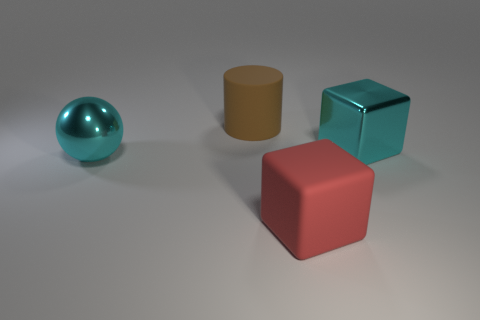Are there any cyan things left of the big cyan cube?
Provide a succinct answer. Yes. There is a large cyan metallic thing to the left of the cyan block; what number of cyan things are to the right of it?
Provide a succinct answer. 1. There is a cylinder that is the same size as the red rubber cube; what is it made of?
Give a very brief answer. Rubber. How many other things are made of the same material as the large cyan cube?
Offer a terse response. 1. There is a brown matte cylinder; how many large matte things are on the right side of it?
Make the answer very short. 1. How many cylinders are either large blue matte objects or brown rubber objects?
Provide a short and direct response. 1. How many other objects are there of the same color as the shiny ball?
Offer a terse response. 1. Is the cylinder made of the same material as the cyan thing that is behind the ball?
Ensure brevity in your answer.  No. How many things are either big cyan objects that are on the left side of the big brown object or brown things?
Ensure brevity in your answer.  2. What shape is the object that is both in front of the cyan metallic block and to the right of the metallic ball?
Keep it short and to the point. Cube. 